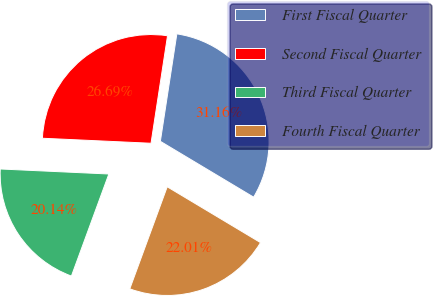<chart> <loc_0><loc_0><loc_500><loc_500><pie_chart><fcel>First Fiscal Quarter<fcel>Second Fiscal Quarter<fcel>Third Fiscal Quarter<fcel>Fourth Fiscal Quarter<nl><fcel>31.16%<fcel>26.69%<fcel>20.14%<fcel>22.01%<nl></chart> 